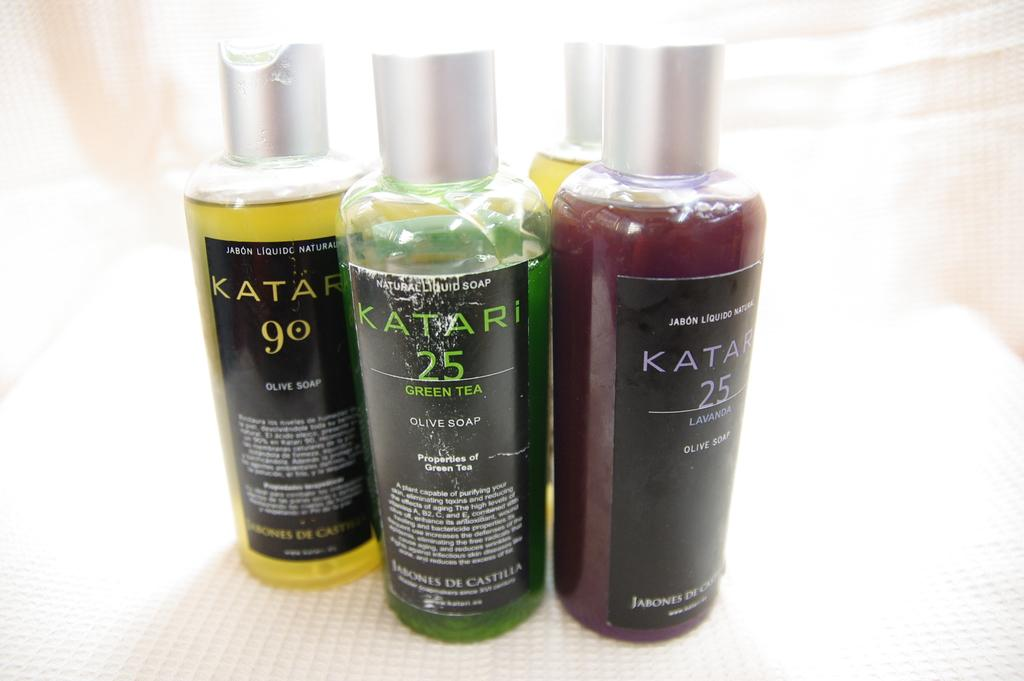<image>
Render a clear and concise summary of the photo. The brand Katari sells different scented soaps in a bottle. 